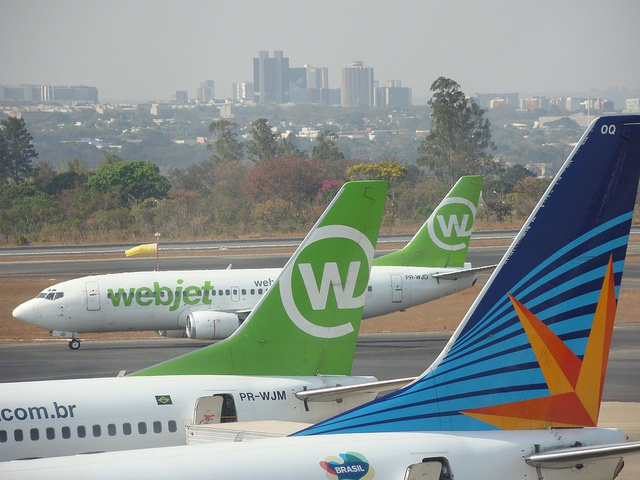Describe the objects in this image and their specific colors. I can see airplane in darkgray, navy, lightgray, and teal tones, airplane in darkgray, lightgray, and green tones, and airplane in darkgray, lightgray, gray, and green tones in this image. 